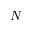<formula> <loc_0><loc_0><loc_500><loc_500>N</formula> 